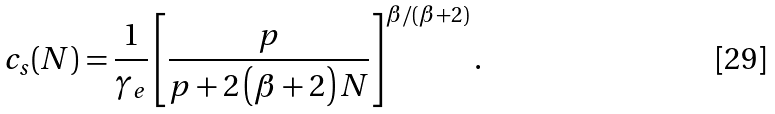<formula> <loc_0><loc_0><loc_500><loc_500>c _ { s } ( N ) = \frac { 1 } { \gamma _ { e } } \left [ \frac { p } { p + 2 \left ( \beta + 2 \right ) N } \right ] ^ { \beta / ( \beta + 2 ) } .</formula> 